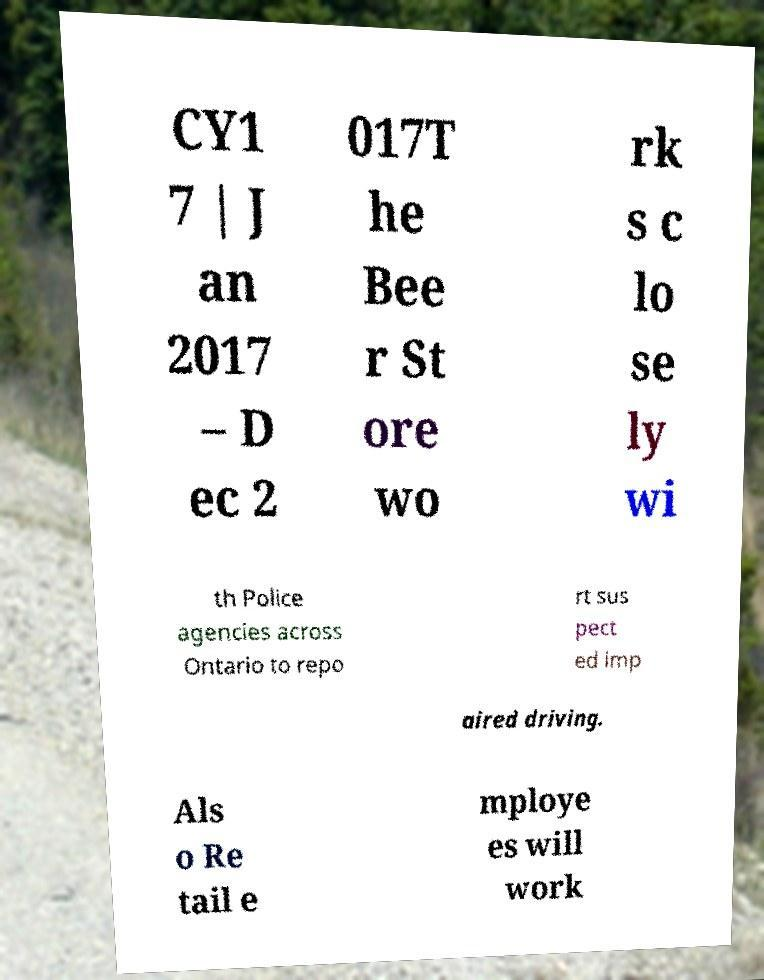Please identify and transcribe the text found in this image. CY1 7 | J an 2017 – D ec 2 017T he Bee r St ore wo rk s c lo se ly wi th Police agencies across Ontario to repo rt sus pect ed imp aired driving. Als o Re tail e mploye es will work 